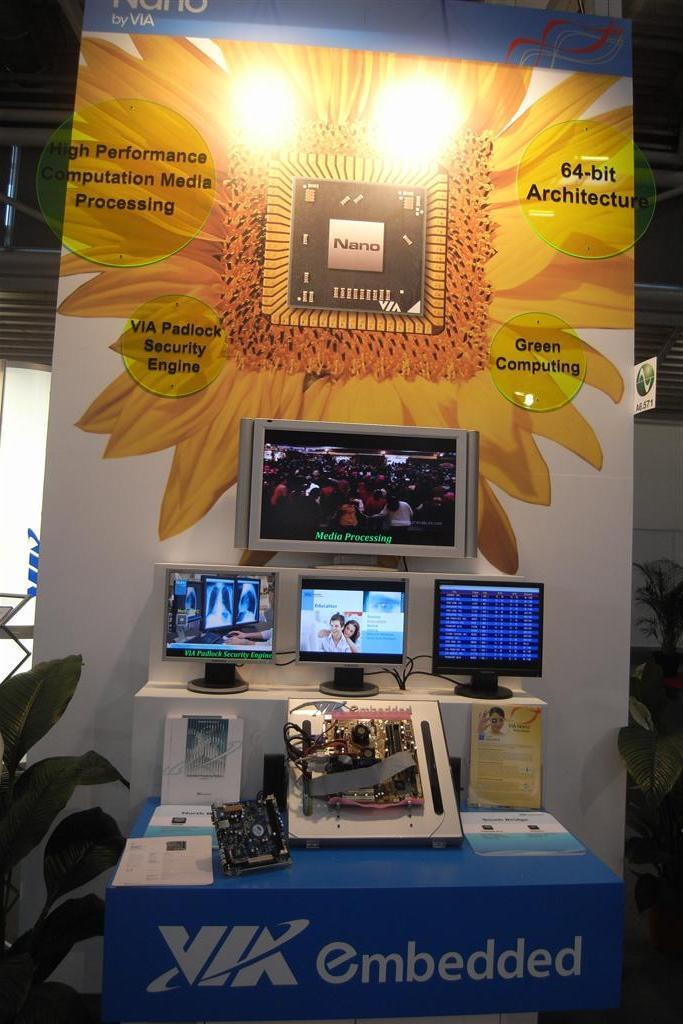<image>
Provide a brief description of the given image. a display of NANO sponsored by VIA Embedded 